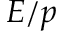<formula> <loc_0><loc_0><loc_500><loc_500>E / p</formula> 